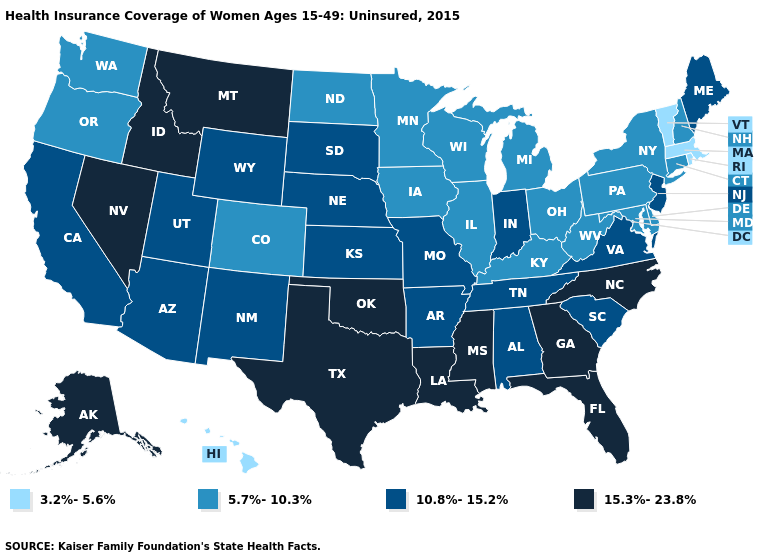What is the value of Mississippi?
Give a very brief answer. 15.3%-23.8%. Does Georgia have the highest value in the South?
Write a very short answer. Yes. What is the value of Tennessee?
Give a very brief answer. 10.8%-15.2%. Does Vermont have the lowest value in the USA?
Give a very brief answer. Yes. What is the value of New Mexico?
Concise answer only. 10.8%-15.2%. Does Arkansas have a lower value than Oregon?
Short answer required. No. Does South Dakota have a lower value than Virginia?
Write a very short answer. No. Which states have the lowest value in the MidWest?
Quick response, please. Illinois, Iowa, Michigan, Minnesota, North Dakota, Ohio, Wisconsin. Does New Mexico have a lower value than Montana?
Keep it brief. Yes. Name the states that have a value in the range 15.3%-23.8%?
Quick response, please. Alaska, Florida, Georgia, Idaho, Louisiana, Mississippi, Montana, Nevada, North Carolina, Oklahoma, Texas. Name the states that have a value in the range 15.3%-23.8%?
Give a very brief answer. Alaska, Florida, Georgia, Idaho, Louisiana, Mississippi, Montana, Nevada, North Carolina, Oklahoma, Texas. Does Rhode Island have the lowest value in the USA?
Quick response, please. Yes. What is the highest value in states that border Maryland?
Short answer required. 10.8%-15.2%. What is the highest value in states that border Colorado?
Answer briefly. 15.3%-23.8%. Does Maine have the same value as Utah?
Concise answer only. Yes. 